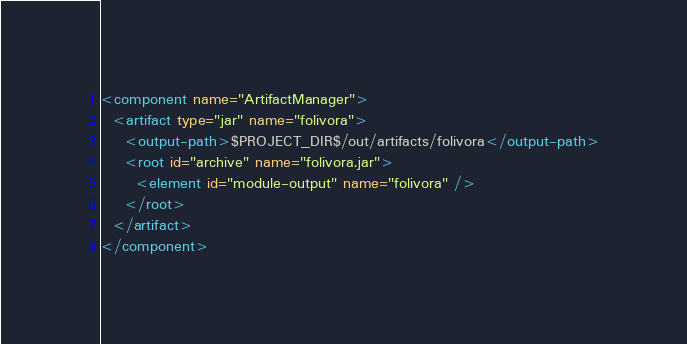<code> <loc_0><loc_0><loc_500><loc_500><_XML_><component name="ArtifactManager">
  <artifact type="jar" name="folivora">
    <output-path>$PROJECT_DIR$/out/artifacts/folivora</output-path>
    <root id="archive" name="folivora.jar">
      <element id="module-output" name="folivora" />
    </root>
  </artifact>
</component></code> 